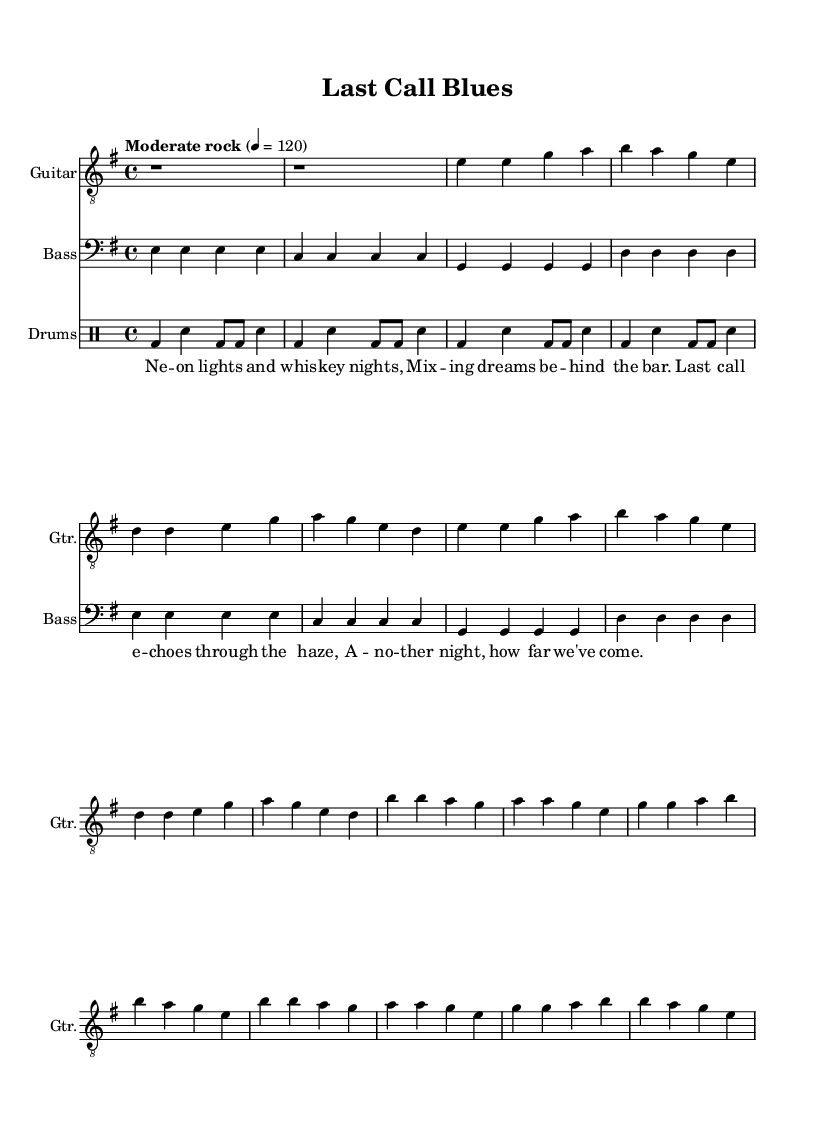What is the key signature of this music? The key signature is indicated at the beginning of the section labeled "global." It shows an E minor key, which has one sharp (F#).
Answer: E minor What is the time signature of this music? The time signature is also located in the "global" section, where it is noted as 4/4 time, meaning there are four beats per measure.
Answer: 4/4 What is the tempo marking for this piece? The tempo marking is found in the "global" section, indicating a moderate rock tempo of 120 beats per minute.
Answer: Moderate rock 4 = 120 How many measures are in the verse section? By counting the measures in the "verse" lyrics section of the score, there are eight distinct lines, indicating that there are eight measures.
Answer: 8 What instrument plays the main theme in this piece? The main theme is played on the guitar, as indicated by the instrumental name "Guitar" above the corresponding staff.
Answer: Guitar Which instrument plays a simplified bass line? The “Bass” staff indicates that a bass instrument plays the simplified bass line. It is labeled as such in the score.
Answer: Bass How does the drum pattern contribute to the song's rock feel? The drum pattern is a basic rock beat, characterized by a consistent bass drum and snare rhythm that creates a driving energy typical in rock music. This is derived from the rhythmic notation in the drum staff.
Answer: Basic rock beat 